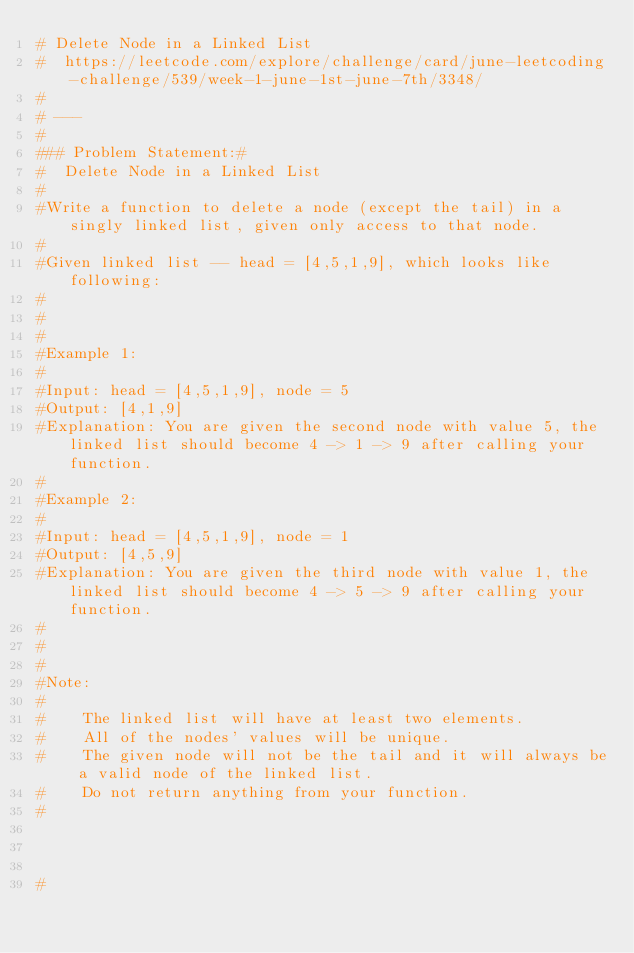<code> <loc_0><loc_0><loc_500><loc_500><_Python_># Delete Node in a Linked List
#  https://leetcode.com/explore/challenge/card/june-leetcoding-challenge/539/week-1-june-1st-june-7th/3348/
#
# ---
#
### Problem Statement:#  
#  Delete Node in a Linked List
#
#Write a function to delete a node (except the tail) in a singly linked list, given only access to that node.
#
#Given linked list -- head = [4,5,1,9], which looks like following:
#
# 
#
#Example 1:
#
#Input: head = [4,5,1,9], node = 5
#Output: [4,1,9]
#Explanation: You are given the second node with value 5, the linked list should become 4 -> 1 -> 9 after calling your function.
#
#Example 2:
#
#Input: head = [4,5,1,9], node = 1
#Output: [4,5,9]
#Explanation: You are given the third node with value 1, the linked list should become 4 -> 5 -> 9 after calling your function.
#
# 
#
#Note:
#
#    The linked list will have at least two elements.
#    All of the nodes' values will be unique.
#    The given node will not be the tail and it will always be a valid node of the linked list.
#    Do not return anything from your function.
#



#</code> 